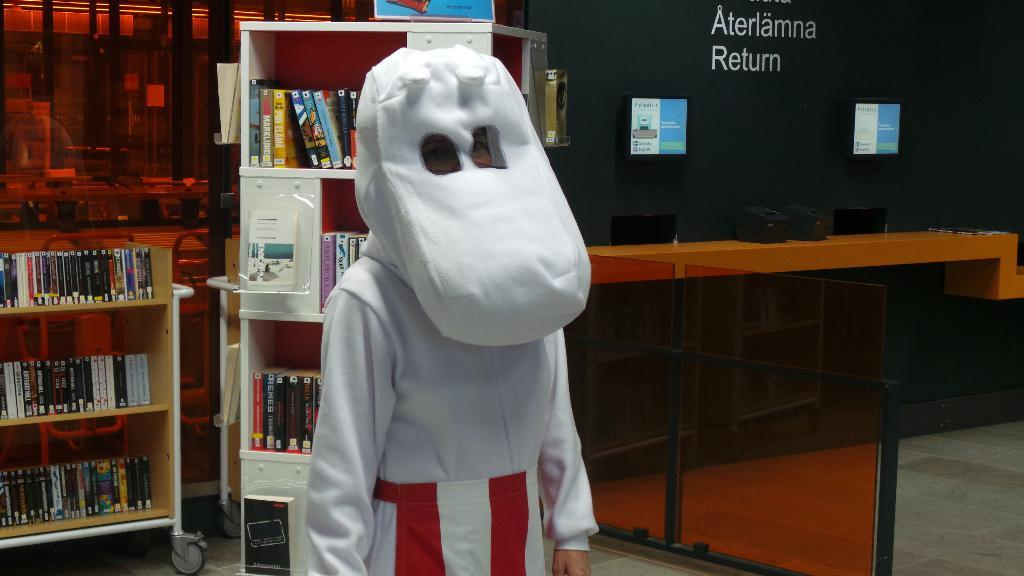What can be seen on the shelves in the image? There are different types of books on the shelves in the image. Can you describe the person standing in the center of the image? The person is wearing a white costume. What type of leather is used to make the sack in the image? There is no sack present in the image, so it is not possible to determine the type of leather used. 